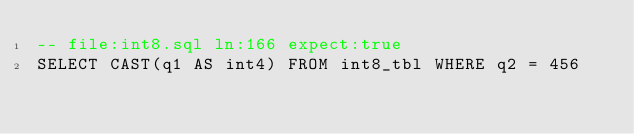Convert code to text. <code><loc_0><loc_0><loc_500><loc_500><_SQL_>-- file:int8.sql ln:166 expect:true
SELECT CAST(q1 AS int4) FROM int8_tbl WHERE q2 = 456
</code> 